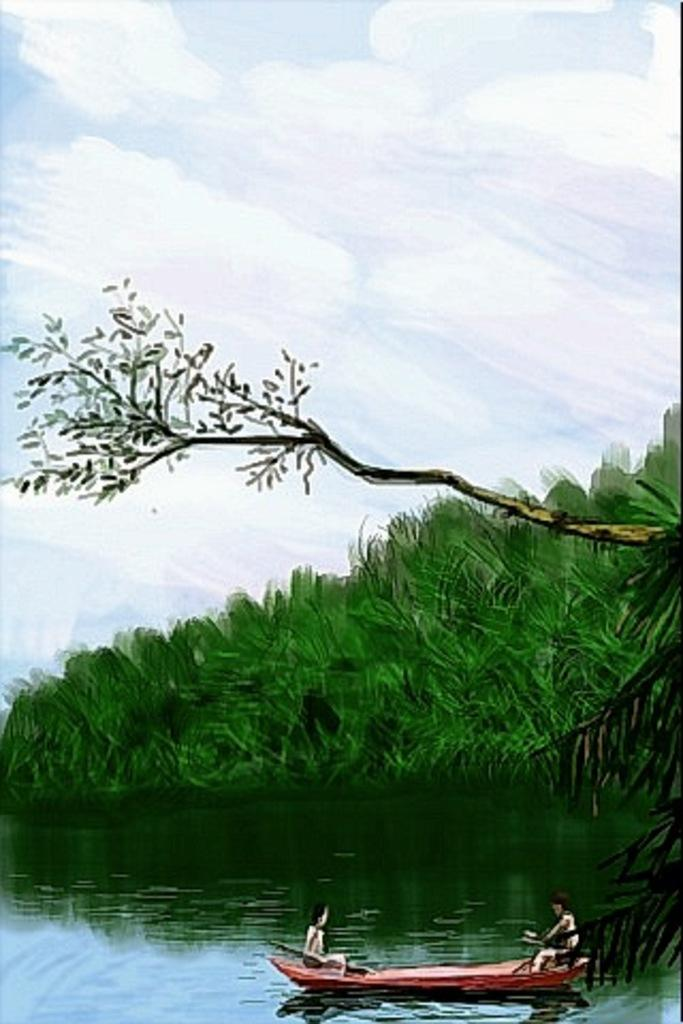What type of artwork is depicted in the image? The image is a painting. How many people are in the painting? There are two persons in the painting. What are the persons doing in the painting? The persons are on a boat. What is the natural environment like in the painting? There is water, trees, and the sky visible in the painting. What is the condition of the sky in the painting? The sky is visible in the background of the painting, and there are clouds in the sky. What type of flame can be seen burning on the boat in the painting? There is no flame present in the painting; it features two people on a boat in a natural environment. What arithmetic problem is being solved by the trees in the painting? There is no arithmetic problem being solved by the trees in the painting; they are simply part of the natural environment. 